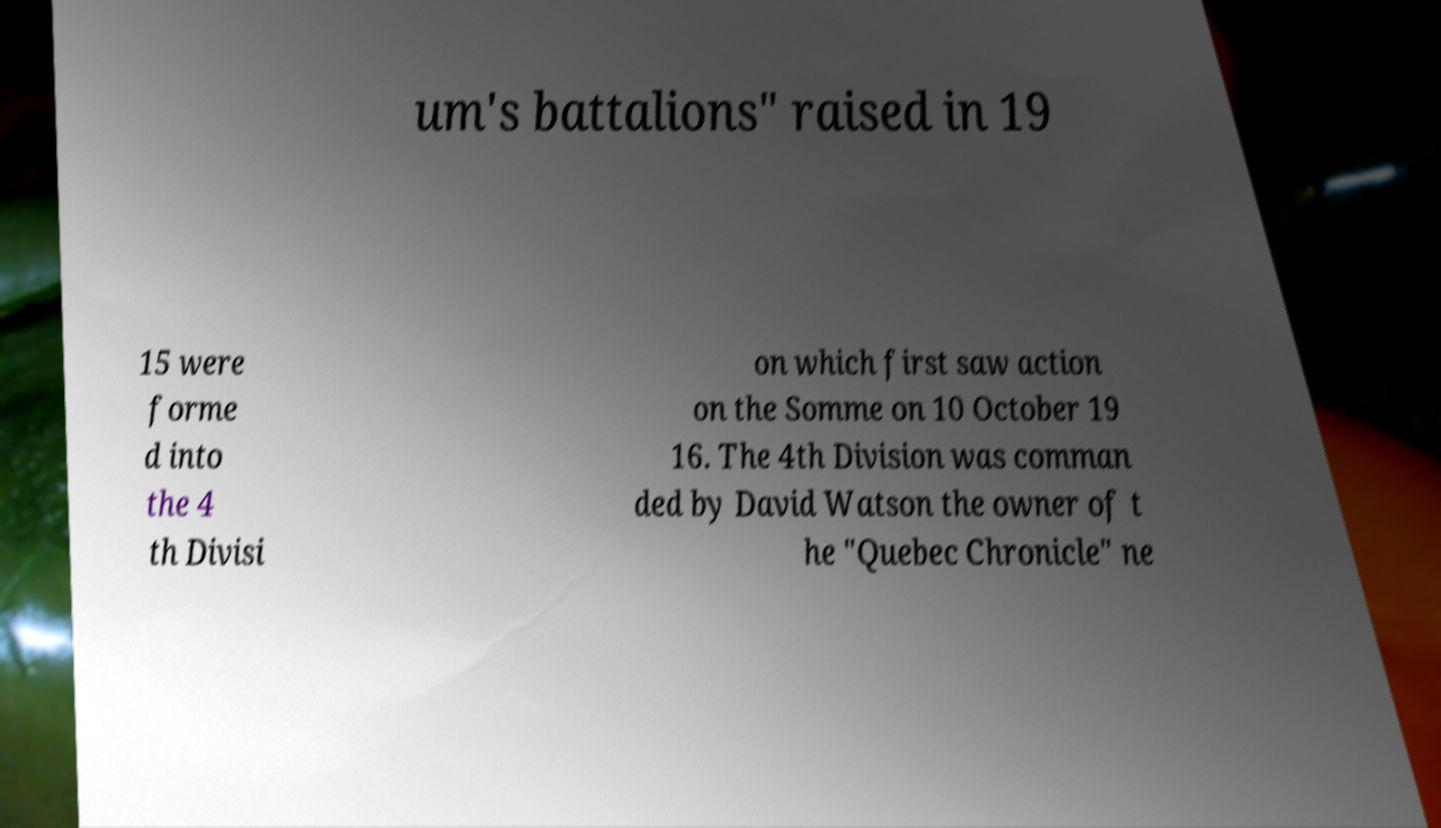Could you extract and type out the text from this image? um's battalions" raised in 19 15 were forme d into the 4 th Divisi on which first saw action on the Somme on 10 October 19 16. The 4th Division was comman ded by David Watson the owner of t he "Quebec Chronicle" ne 